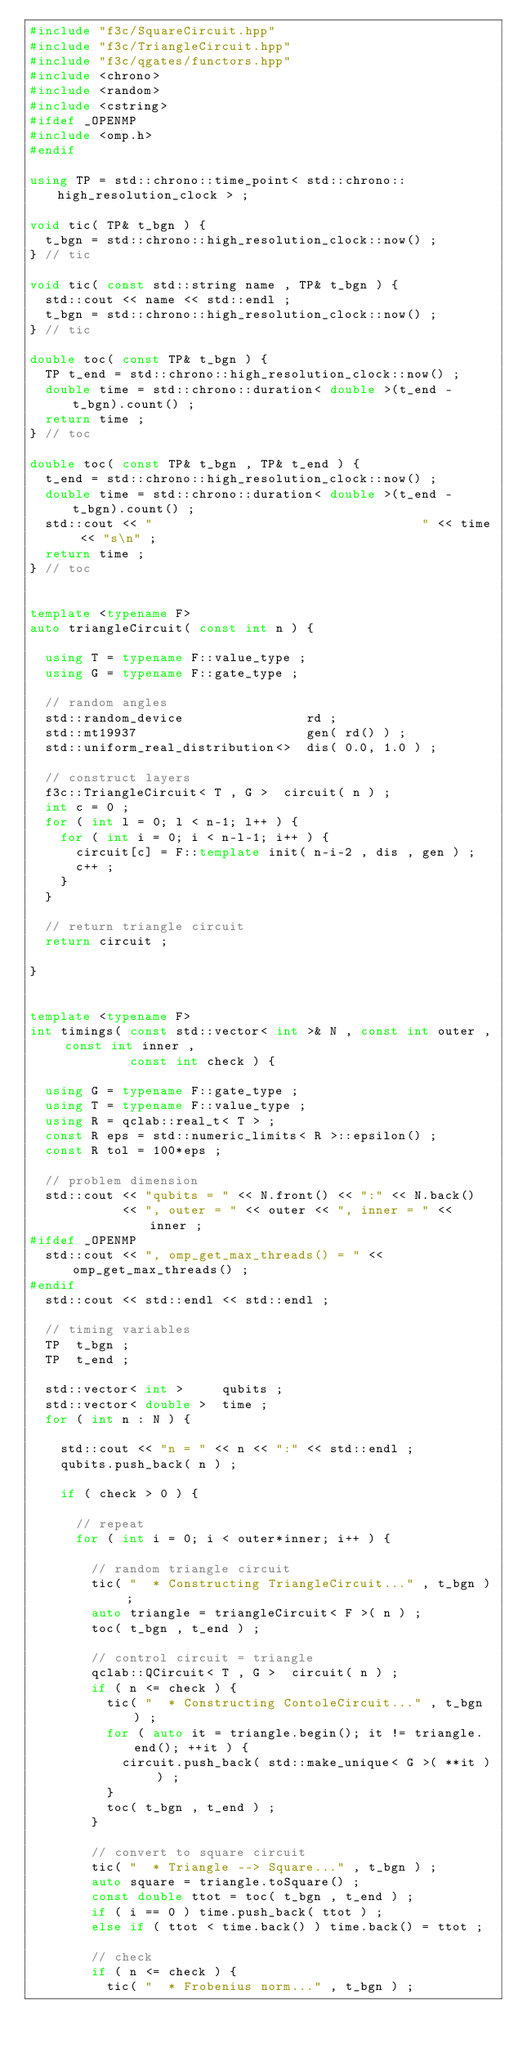Convert code to text. <code><loc_0><loc_0><loc_500><loc_500><_C++_>#include "f3c/SquareCircuit.hpp"
#include "f3c/TriangleCircuit.hpp"
#include "f3c/qgates/functors.hpp"
#include <chrono>
#include <random>
#include <cstring>
#ifdef _OPENMP
#include <omp.h>
#endif

using TP = std::chrono::time_point< std::chrono::high_resolution_clock > ;

void tic( TP& t_bgn ) {
  t_bgn = std::chrono::high_resolution_clock::now() ;
} // tic

void tic( const std::string name , TP& t_bgn ) {
  std::cout << name << std::endl ;
  t_bgn = std::chrono::high_resolution_clock::now() ;
} // tic

double toc( const TP& t_bgn ) {
  TP t_end = std::chrono::high_resolution_clock::now() ;
  double time = std::chrono::duration< double >(t_end - t_bgn).count() ;
  return time ;
} // toc

double toc( const TP& t_bgn , TP& t_end ) {
  t_end = std::chrono::high_resolution_clock::now() ;
  double time = std::chrono::duration< double >(t_end - t_bgn).count() ;
  std::cout << "                                   " << time << "s\n" ;
  return time ;
} // toc


template <typename F>
auto triangleCircuit( const int n ) {

  using T = typename F::value_type ;
  using G = typename F::gate_type ;

  // random angles
  std::random_device                rd ;
  std::mt19937                      gen( rd() ) ;
  std::uniform_real_distribution<>  dis( 0.0, 1.0 ) ;

  // construct layers
  f3c::TriangleCircuit< T , G >  circuit( n ) ;
  int c = 0 ;
  for ( int l = 0; l < n-1; l++ ) {
    for ( int i = 0; i < n-l-1; i++ ) {
      circuit[c] = F::template init( n-i-2 , dis , gen ) ;
      c++ ;
    }
  }

  // return triangle circuit
  return circuit ;

}


template <typename F>
int timings( const std::vector< int >& N , const int outer , const int inner ,
             const int check ) {

  using G = typename F::gate_type ;
  using T = typename F::value_type ;
  using R = qclab::real_t< T > ;
  const R eps = std::numeric_limits< R >::epsilon() ;
  const R tol = 100*eps ;

  // problem dimension
  std::cout << "qubits = " << N.front() << ":" << N.back()
            << ", outer = " << outer << ", inner = " << inner ;
#ifdef _OPENMP
  std::cout << ", omp_get_max_threads() = " << omp_get_max_threads() ;
#endif
  std::cout << std::endl << std::endl ;

  // timing variables
  TP  t_bgn ;
  TP  t_end ;

  std::vector< int >     qubits ;
  std::vector< double >  time ;
  for ( int n : N ) {

    std::cout << "n = " << n << ":" << std::endl ;
    qubits.push_back( n ) ;

    if ( check > 0 ) {

      // repeat
      for ( int i = 0; i < outer*inner; i++ ) {

        // random triangle circuit
        tic( "  * Constructing TriangleCircuit..." , t_bgn ) ;
        auto triangle = triangleCircuit< F >( n ) ;
        toc( t_bgn , t_end ) ;

        // control circuit = triangle
        qclab::QCircuit< T , G >  circuit( n ) ;
        if ( n <= check ) {
          tic( "  * Constructing ContoleCircuit..." , t_bgn ) ;
          for ( auto it = triangle.begin(); it != triangle.end(); ++it ) {
            circuit.push_back( std::make_unique< G >( **it ) ) ;
          }
          toc( t_bgn , t_end ) ;
        }

        // convert to square circuit
        tic( "  * Triangle --> Square..." , t_bgn ) ;
        auto square = triangle.toSquare() ;
        const double ttot = toc( t_bgn , t_end ) ;
        if ( i == 0 ) time.push_back( ttot ) ;
        else if ( ttot < time.back() ) time.back() = ttot ;

        // check
        if ( n <= check ) {
          tic( "  * Frobenius norm..." , t_bgn ) ;</code> 